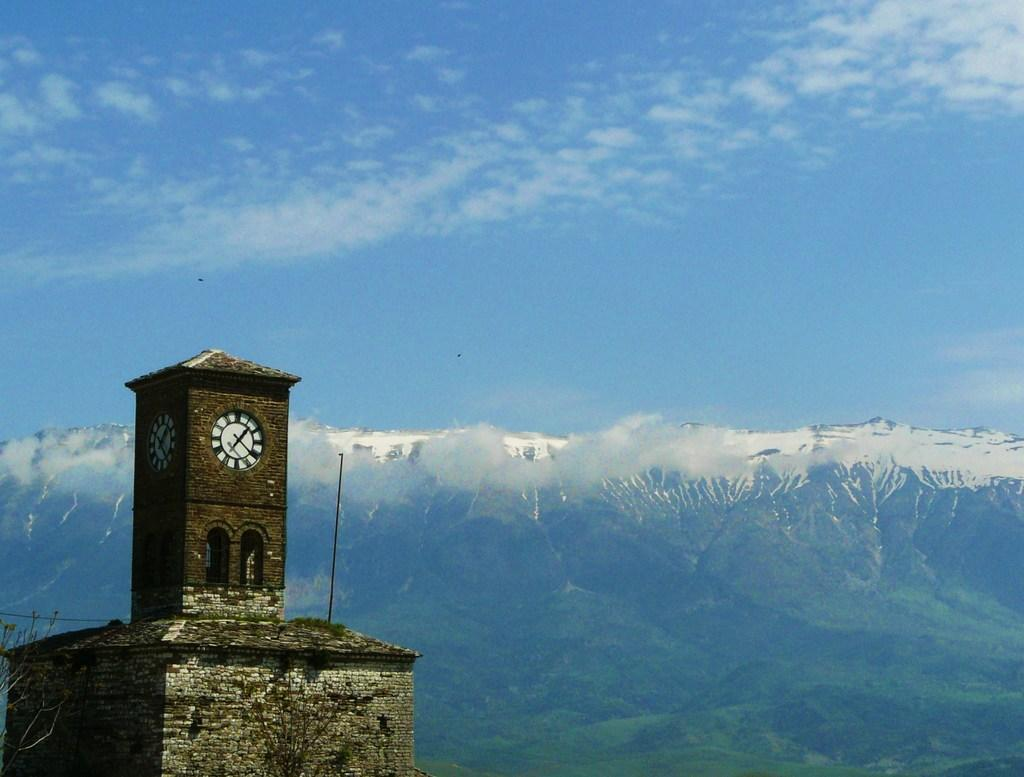What is the main structure in the image? There is a clock tower in the image. What other buildings or structures can be seen in the image? There is a building in the image. What is the pole used for in the image? The purpose of the pole is not specified in the image. What is visible in the background of the image? The sky, clouds, and hills are visible in the image. What type of dress is the mountain wearing in the image? There is no mountain present in the image, and therefore no dress can be associated with it. 